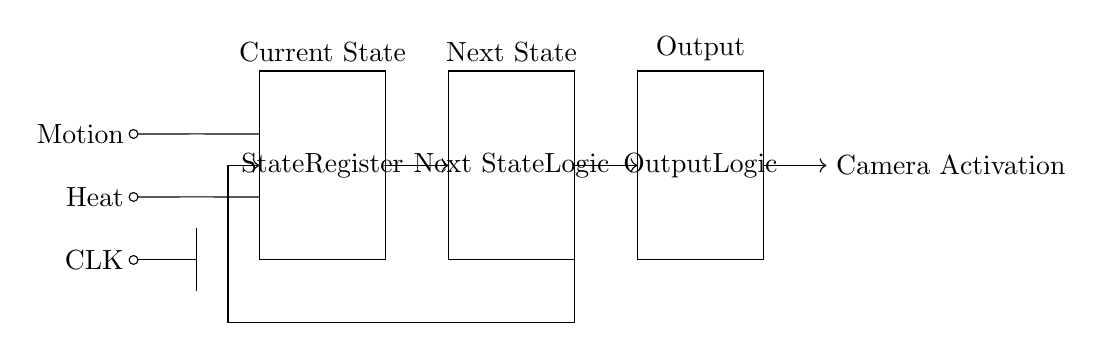What are the input sensors in this circuit? The circuit diagram shows two input sensors: Motion and Heat, which are indicated by two lines leading from the left side to the state register.
Answer: Motion and Heat What is the main function of the State Register? The State Register is responsible for storing the current state of the system. It receives inputs from the sensors and decides the next state based on the input logic provided.
Answer: Storing the current state What does the Output Logic component control? The Output Logic component controls the activation of the camera based on the states processed by the previous components. It produces the camera activation output signal based on the current input conditions.
Answer: Camera activation How many main components are there in this circuit? The diagram features three main components: State Register, Next State Logic, and Output Logic, along with input sensors.
Answer: Three What is the purpose of the Next State Logic? The Next State Logic processes the current state and input signals to determine what the next state of the system should be. It redirects the flow based on the logic derived from the State Register inputs.
Answer: Determine next state What is the relationship between input sensors and the State Register? The input sensors feed their signals into the State Register, which uses this data to update the current state and drive further logic in the system. This connectivity is shown by the directed connections from the sensors to the register.
Answer: Feed signals to update state 